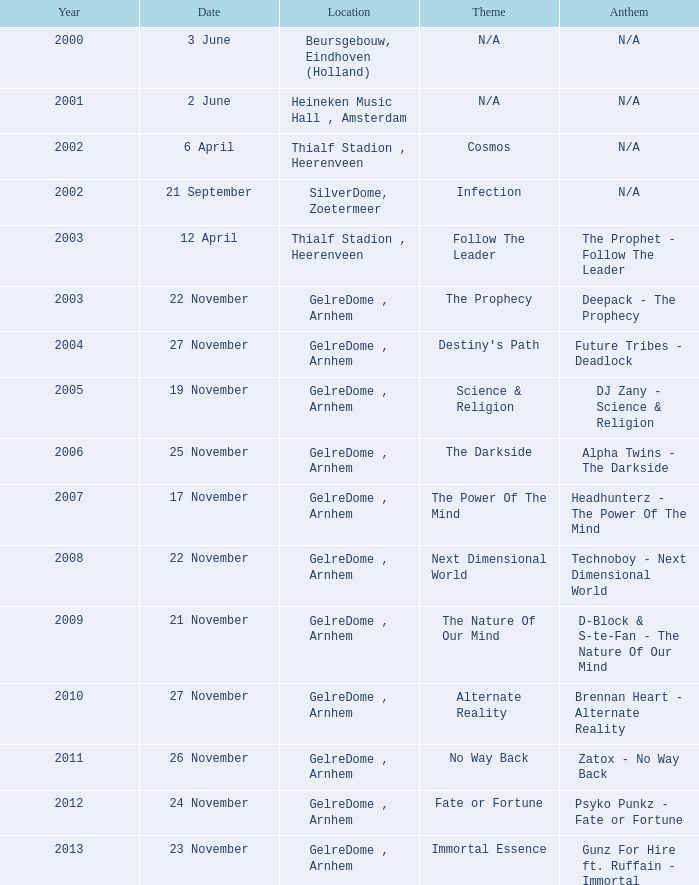In which year was the gelredome in arnhem first associated with technoboy's anthem "next dimensional world"? 2008.0. 